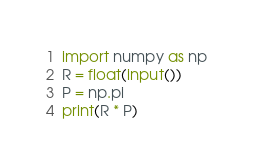<code> <loc_0><loc_0><loc_500><loc_500><_Python_>import numpy as np
R = float(input())
P = np.pi
print(R * P)</code> 